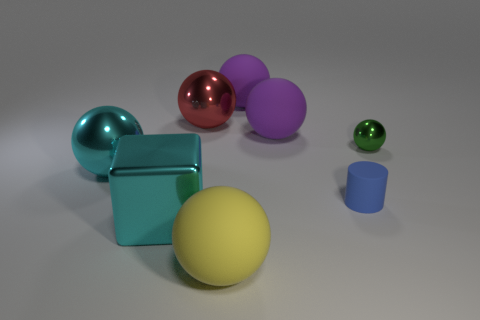Are there any other things that are the same shape as the tiny rubber object?
Your answer should be compact. No. There is a shiny ball that is on the right side of the big yellow matte sphere; is it the same color as the big rubber thing that is in front of the blue rubber thing?
Keep it short and to the point. No. What is the material of the sphere in front of the tiny thing in front of the small green ball?
Your answer should be very brief. Rubber. There is a metal block that is the same size as the yellow thing; what color is it?
Keep it short and to the point. Cyan. There is a large red metallic thing; is it the same shape as the large purple rubber thing behind the large red metal thing?
Offer a very short reply. Yes. What number of large cyan spheres are in front of the large cyan thing in front of the cyan shiny thing behind the large cyan shiny block?
Keep it short and to the point. 0. There is a matte sphere that is left of the big matte ball behind the red sphere; what size is it?
Your response must be concise. Large. What is the size of the cyan ball that is made of the same material as the green ball?
Provide a short and direct response. Large. There is a large thing that is both in front of the big cyan metal ball and on the right side of the big cyan cube; what shape is it?
Offer a very short reply. Sphere. Is the number of big red things that are in front of the small green shiny ball the same as the number of blocks?
Your answer should be very brief. No. 